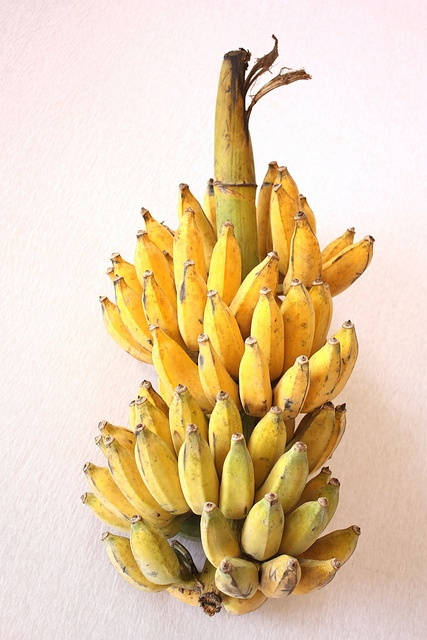Describe the objects in this image and their specific colors. I can see a banana in lightgray, orange, gold, and olive tones in this image. 